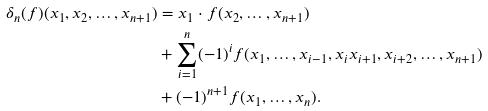<formula> <loc_0><loc_0><loc_500><loc_500>\delta _ { n } ( f ) ( x _ { 1 } , x _ { 2 } , \dots , x _ { n + 1 } ) & = x _ { 1 } \cdot f ( x _ { 2 } , \dots , x _ { n + 1 } ) \\ & + \sum _ { i = 1 } ^ { n } ( - 1 ) ^ { i } f ( x _ { 1 } , \dots , x _ { i - 1 } , x _ { i } x _ { i + 1 } , x _ { i + 2 } , \dots , x _ { n + 1 } ) \\ & + ( - 1 ) ^ { n + 1 } f ( x _ { 1 } , \dots , x _ { n } ) .</formula> 